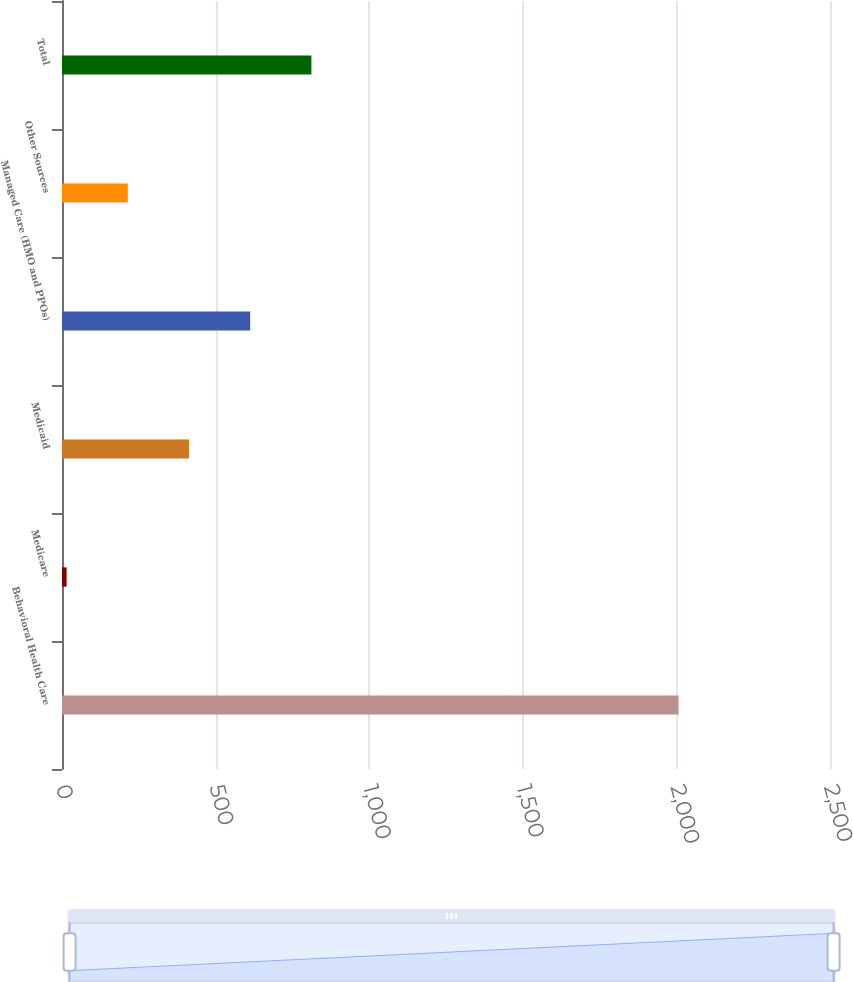Convert chart. <chart><loc_0><loc_0><loc_500><loc_500><bar_chart><fcel>Behavioral Health Care<fcel>Medicare<fcel>Medicaid<fcel>Managed Care (HMO and PPOs)<fcel>Other Sources<fcel>Total<nl><fcel>2007<fcel>15<fcel>413.4<fcel>612.6<fcel>214.2<fcel>811.8<nl></chart> 